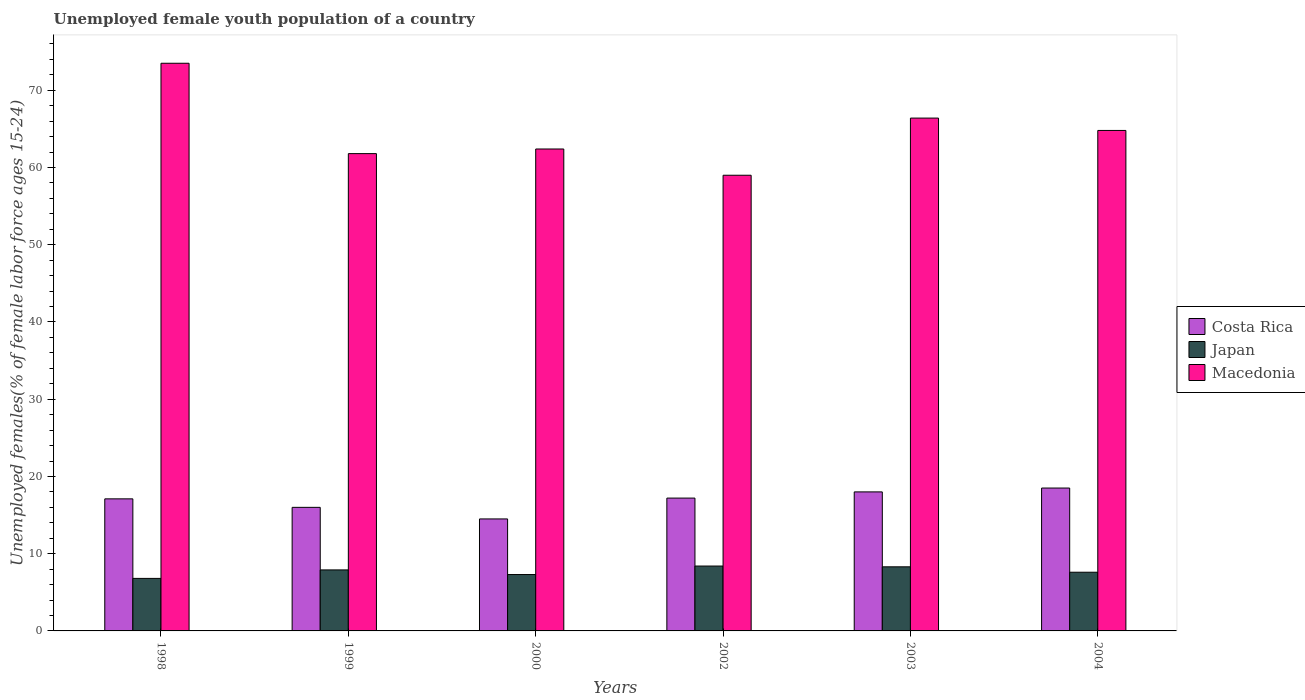Are the number of bars on each tick of the X-axis equal?
Keep it short and to the point. Yes. How many bars are there on the 5th tick from the left?
Provide a short and direct response. 3. What is the percentage of unemployed female youth population in Macedonia in 1998?
Your response must be concise. 73.5. Across all years, what is the maximum percentage of unemployed female youth population in Japan?
Offer a terse response. 8.4. Across all years, what is the minimum percentage of unemployed female youth population in Costa Rica?
Your response must be concise. 14.5. In which year was the percentage of unemployed female youth population in Macedonia maximum?
Your answer should be very brief. 1998. What is the total percentage of unemployed female youth population in Costa Rica in the graph?
Ensure brevity in your answer.  101.3. What is the difference between the percentage of unemployed female youth population in Macedonia in 1998 and that in 1999?
Offer a terse response. 11.7. What is the difference between the percentage of unemployed female youth population in Japan in 1998 and the percentage of unemployed female youth population in Costa Rica in 2002?
Your answer should be very brief. -10.4. What is the average percentage of unemployed female youth population in Japan per year?
Your answer should be very brief. 7.72. In the year 2003, what is the difference between the percentage of unemployed female youth population in Macedonia and percentage of unemployed female youth population in Japan?
Your answer should be very brief. 58.1. What is the ratio of the percentage of unemployed female youth population in Japan in 1999 to that in 2002?
Offer a very short reply. 0.94. Is the percentage of unemployed female youth population in Macedonia in 1998 less than that in 2000?
Keep it short and to the point. No. What is the difference between the highest and the second highest percentage of unemployed female youth population in Costa Rica?
Offer a terse response. 0.5. What does the 3rd bar from the left in 2003 represents?
Ensure brevity in your answer.  Macedonia. What does the 3rd bar from the right in 2000 represents?
Your answer should be very brief. Costa Rica. How many bars are there?
Give a very brief answer. 18. Are the values on the major ticks of Y-axis written in scientific E-notation?
Provide a short and direct response. No. Does the graph contain grids?
Your answer should be compact. No. How many legend labels are there?
Provide a short and direct response. 3. How are the legend labels stacked?
Your answer should be compact. Vertical. What is the title of the graph?
Your answer should be compact. Unemployed female youth population of a country. Does "Malta" appear as one of the legend labels in the graph?
Ensure brevity in your answer.  No. What is the label or title of the Y-axis?
Ensure brevity in your answer.  Unemployed females(% of female labor force ages 15-24). What is the Unemployed females(% of female labor force ages 15-24) of Costa Rica in 1998?
Your response must be concise. 17.1. What is the Unemployed females(% of female labor force ages 15-24) of Japan in 1998?
Your response must be concise. 6.8. What is the Unemployed females(% of female labor force ages 15-24) of Macedonia in 1998?
Offer a very short reply. 73.5. What is the Unemployed females(% of female labor force ages 15-24) in Japan in 1999?
Your answer should be very brief. 7.9. What is the Unemployed females(% of female labor force ages 15-24) of Macedonia in 1999?
Keep it short and to the point. 61.8. What is the Unemployed females(% of female labor force ages 15-24) in Japan in 2000?
Give a very brief answer. 7.3. What is the Unemployed females(% of female labor force ages 15-24) of Macedonia in 2000?
Offer a terse response. 62.4. What is the Unemployed females(% of female labor force ages 15-24) of Costa Rica in 2002?
Ensure brevity in your answer.  17.2. What is the Unemployed females(% of female labor force ages 15-24) in Japan in 2002?
Offer a very short reply. 8.4. What is the Unemployed females(% of female labor force ages 15-24) of Japan in 2003?
Your answer should be very brief. 8.3. What is the Unemployed females(% of female labor force ages 15-24) of Macedonia in 2003?
Provide a short and direct response. 66.4. What is the Unemployed females(% of female labor force ages 15-24) of Japan in 2004?
Ensure brevity in your answer.  7.6. What is the Unemployed females(% of female labor force ages 15-24) in Macedonia in 2004?
Provide a succinct answer. 64.8. Across all years, what is the maximum Unemployed females(% of female labor force ages 15-24) in Japan?
Your response must be concise. 8.4. Across all years, what is the maximum Unemployed females(% of female labor force ages 15-24) of Macedonia?
Offer a very short reply. 73.5. Across all years, what is the minimum Unemployed females(% of female labor force ages 15-24) of Costa Rica?
Offer a terse response. 14.5. Across all years, what is the minimum Unemployed females(% of female labor force ages 15-24) of Japan?
Your response must be concise. 6.8. Across all years, what is the minimum Unemployed females(% of female labor force ages 15-24) in Macedonia?
Your answer should be compact. 59. What is the total Unemployed females(% of female labor force ages 15-24) in Costa Rica in the graph?
Ensure brevity in your answer.  101.3. What is the total Unemployed females(% of female labor force ages 15-24) in Japan in the graph?
Your answer should be compact. 46.3. What is the total Unemployed females(% of female labor force ages 15-24) in Macedonia in the graph?
Your answer should be compact. 387.9. What is the difference between the Unemployed females(% of female labor force ages 15-24) in Japan in 1998 and that in 1999?
Give a very brief answer. -1.1. What is the difference between the Unemployed females(% of female labor force ages 15-24) of Costa Rica in 1998 and that in 2000?
Your answer should be compact. 2.6. What is the difference between the Unemployed females(% of female labor force ages 15-24) in Japan in 1998 and that in 2002?
Your answer should be compact. -1.6. What is the difference between the Unemployed females(% of female labor force ages 15-24) in Macedonia in 1998 and that in 2002?
Offer a terse response. 14.5. What is the difference between the Unemployed females(% of female labor force ages 15-24) of Japan in 1998 and that in 2003?
Your answer should be very brief. -1.5. What is the difference between the Unemployed females(% of female labor force ages 15-24) in Macedonia in 1998 and that in 2003?
Provide a short and direct response. 7.1. What is the difference between the Unemployed females(% of female labor force ages 15-24) of Costa Rica in 1998 and that in 2004?
Offer a terse response. -1.4. What is the difference between the Unemployed females(% of female labor force ages 15-24) of Costa Rica in 1999 and that in 2000?
Give a very brief answer. 1.5. What is the difference between the Unemployed females(% of female labor force ages 15-24) in Japan in 1999 and that in 2002?
Your answer should be very brief. -0.5. What is the difference between the Unemployed females(% of female labor force ages 15-24) of Macedonia in 1999 and that in 2002?
Give a very brief answer. 2.8. What is the difference between the Unemployed females(% of female labor force ages 15-24) of Costa Rica in 1999 and that in 2003?
Offer a very short reply. -2. What is the difference between the Unemployed females(% of female labor force ages 15-24) in Macedonia in 1999 and that in 2003?
Your answer should be very brief. -4.6. What is the difference between the Unemployed females(% of female labor force ages 15-24) in Japan in 2000 and that in 2002?
Keep it short and to the point. -1.1. What is the difference between the Unemployed females(% of female labor force ages 15-24) in Macedonia in 2000 and that in 2002?
Ensure brevity in your answer.  3.4. What is the difference between the Unemployed females(% of female labor force ages 15-24) of Costa Rica in 2000 and that in 2003?
Offer a very short reply. -3.5. What is the difference between the Unemployed females(% of female labor force ages 15-24) of Japan in 2000 and that in 2004?
Give a very brief answer. -0.3. What is the difference between the Unemployed females(% of female labor force ages 15-24) in Costa Rica in 2002 and that in 2003?
Provide a succinct answer. -0.8. What is the difference between the Unemployed females(% of female labor force ages 15-24) in Macedonia in 2002 and that in 2003?
Offer a terse response. -7.4. What is the difference between the Unemployed females(% of female labor force ages 15-24) in Japan in 2002 and that in 2004?
Give a very brief answer. 0.8. What is the difference between the Unemployed females(% of female labor force ages 15-24) in Macedonia in 2002 and that in 2004?
Offer a very short reply. -5.8. What is the difference between the Unemployed females(% of female labor force ages 15-24) in Costa Rica in 2003 and that in 2004?
Keep it short and to the point. -0.5. What is the difference between the Unemployed females(% of female labor force ages 15-24) of Japan in 2003 and that in 2004?
Your answer should be very brief. 0.7. What is the difference between the Unemployed females(% of female labor force ages 15-24) in Macedonia in 2003 and that in 2004?
Give a very brief answer. 1.6. What is the difference between the Unemployed females(% of female labor force ages 15-24) of Costa Rica in 1998 and the Unemployed females(% of female labor force ages 15-24) of Macedonia in 1999?
Offer a very short reply. -44.7. What is the difference between the Unemployed females(% of female labor force ages 15-24) in Japan in 1998 and the Unemployed females(% of female labor force ages 15-24) in Macedonia in 1999?
Your response must be concise. -55. What is the difference between the Unemployed females(% of female labor force ages 15-24) of Costa Rica in 1998 and the Unemployed females(% of female labor force ages 15-24) of Japan in 2000?
Ensure brevity in your answer.  9.8. What is the difference between the Unemployed females(% of female labor force ages 15-24) of Costa Rica in 1998 and the Unemployed females(% of female labor force ages 15-24) of Macedonia in 2000?
Make the answer very short. -45.3. What is the difference between the Unemployed females(% of female labor force ages 15-24) in Japan in 1998 and the Unemployed females(% of female labor force ages 15-24) in Macedonia in 2000?
Ensure brevity in your answer.  -55.6. What is the difference between the Unemployed females(% of female labor force ages 15-24) of Costa Rica in 1998 and the Unemployed females(% of female labor force ages 15-24) of Macedonia in 2002?
Provide a succinct answer. -41.9. What is the difference between the Unemployed females(% of female labor force ages 15-24) in Japan in 1998 and the Unemployed females(% of female labor force ages 15-24) in Macedonia in 2002?
Make the answer very short. -52.2. What is the difference between the Unemployed females(% of female labor force ages 15-24) in Costa Rica in 1998 and the Unemployed females(% of female labor force ages 15-24) in Japan in 2003?
Your answer should be compact. 8.8. What is the difference between the Unemployed females(% of female labor force ages 15-24) of Costa Rica in 1998 and the Unemployed females(% of female labor force ages 15-24) of Macedonia in 2003?
Your answer should be very brief. -49.3. What is the difference between the Unemployed females(% of female labor force ages 15-24) of Japan in 1998 and the Unemployed females(% of female labor force ages 15-24) of Macedonia in 2003?
Your answer should be compact. -59.6. What is the difference between the Unemployed females(% of female labor force ages 15-24) of Costa Rica in 1998 and the Unemployed females(% of female labor force ages 15-24) of Japan in 2004?
Make the answer very short. 9.5. What is the difference between the Unemployed females(% of female labor force ages 15-24) in Costa Rica in 1998 and the Unemployed females(% of female labor force ages 15-24) in Macedonia in 2004?
Provide a short and direct response. -47.7. What is the difference between the Unemployed females(% of female labor force ages 15-24) of Japan in 1998 and the Unemployed females(% of female labor force ages 15-24) of Macedonia in 2004?
Make the answer very short. -58. What is the difference between the Unemployed females(% of female labor force ages 15-24) of Costa Rica in 1999 and the Unemployed females(% of female labor force ages 15-24) of Japan in 2000?
Ensure brevity in your answer.  8.7. What is the difference between the Unemployed females(% of female labor force ages 15-24) in Costa Rica in 1999 and the Unemployed females(% of female labor force ages 15-24) in Macedonia in 2000?
Keep it short and to the point. -46.4. What is the difference between the Unemployed females(% of female labor force ages 15-24) of Japan in 1999 and the Unemployed females(% of female labor force ages 15-24) of Macedonia in 2000?
Offer a terse response. -54.5. What is the difference between the Unemployed females(% of female labor force ages 15-24) of Costa Rica in 1999 and the Unemployed females(% of female labor force ages 15-24) of Macedonia in 2002?
Your answer should be compact. -43. What is the difference between the Unemployed females(% of female labor force ages 15-24) in Japan in 1999 and the Unemployed females(% of female labor force ages 15-24) in Macedonia in 2002?
Give a very brief answer. -51.1. What is the difference between the Unemployed females(% of female labor force ages 15-24) of Costa Rica in 1999 and the Unemployed females(% of female labor force ages 15-24) of Macedonia in 2003?
Make the answer very short. -50.4. What is the difference between the Unemployed females(% of female labor force ages 15-24) of Japan in 1999 and the Unemployed females(% of female labor force ages 15-24) of Macedonia in 2003?
Your response must be concise. -58.5. What is the difference between the Unemployed females(% of female labor force ages 15-24) of Costa Rica in 1999 and the Unemployed females(% of female labor force ages 15-24) of Japan in 2004?
Keep it short and to the point. 8.4. What is the difference between the Unemployed females(% of female labor force ages 15-24) of Costa Rica in 1999 and the Unemployed females(% of female labor force ages 15-24) of Macedonia in 2004?
Provide a succinct answer. -48.8. What is the difference between the Unemployed females(% of female labor force ages 15-24) of Japan in 1999 and the Unemployed females(% of female labor force ages 15-24) of Macedonia in 2004?
Offer a very short reply. -56.9. What is the difference between the Unemployed females(% of female labor force ages 15-24) of Costa Rica in 2000 and the Unemployed females(% of female labor force ages 15-24) of Macedonia in 2002?
Provide a short and direct response. -44.5. What is the difference between the Unemployed females(% of female labor force ages 15-24) of Japan in 2000 and the Unemployed females(% of female labor force ages 15-24) of Macedonia in 2002?
Offer a terse response. -51.7. What is the difference between the Unemployed females(% of female labor force ages 15-24) of Costa Rica in 2000 and the Unemployed females(% of female labor force ages 15-24) of Macedonia in 2003?
Offer a terse response. -51.9. What is the difference between the Unemployed females(% of female labor force ages 15-24) of Japan in 2000 and the Unemployed females(% of female labor force ages 15-24) of Macedonia in 2003?
Make the answer very short. -59.1. What is the difference between the Unemployed females(% of female labor force ages 15-24) of Costa Rica in 2000 and the Unemployed females(% of female labor force ages 15-24) of Macedonia in 2004?
Keep it short and to the point. -50.3. What is the difference between the Unemployed females(% of female labor force ages 15-24) of Japan in 2000 and the Unemployed females(% of female labor force ages 15-24) of Macedonia in 2004?
Your answer should be very brief. -57.5. What is the difference between the Unemployed females(% of female labor force ages 15-24) in Costa Rica in 2002 and the Unemployed females(% of female labor force ages 15-24) in Macedonia in 2003?
Keep it short and to the point. -49.2. What is the difference between the Unemployed females(% of female labor force ages 15-24) in Japan in 2002 and the Unemployed females(% of female labor force ages 15-24) in Macedonia in 2003?
Keep it short and to the point. -58. What is the difference between the Unemployed females(% of female labor force ages 15-24) in Costa Rica in 2002 and the Unemployed females(% of female labor force ages 15-24) in Japan in 2004?
Ensure brevity in your answer.  9.6. What is the difference between the Unemployed females(% of female labor force ages 15-24) in Costa Rica in 2002 and the Unemployed females(% of female labor force ages 15-24) in Macedonia in 2004?
Provide a succinct answer. -47.6. What is the difference between the Unemployed females(% of female labor force ages 15-24) in Japan in 2002 and the Unemployed females(% of female labor force ages 15-24) in Macedonia in 2004?
Keep it short and to the point. -56.4. What is the difference between the Unemployed females(% of female labor force ages 15-24) of Costa Rica in 2003 and the Unemployed females(% of female labor force ages 15-24) of Japan in 2004?
Offer a very short reply. 10.4. What is the difference between the Unemployed females(% of female labor force ages 15-24) in Costa Rica in 2003 and the Unemployed females(% of female labor force ages 15-24) in Macedonia in 2004?
Ensure brevity in your answer.  -46.8. What is the difference between the Unemployed females(% of female labor force ages 15-24) in Japan in 2003 and the Unemployed females(% of female labor force ages 15-24) in Macedonia in 2004?
Give a very brief answer. -56.5. What is the average Unemployed females(% of female labor force ages 15-24) in Costa Rica per year?
Make the answer very short. 16.88. What is the average Unemployed females(% of female labor force ages 15-24) of Japan per year?
Your answer should be compact. 7.72. What is the average Unemployed females(% of female labor force ages 15-24) in Macedonia per year?
Give a very brief answer. 64.65. In the year 1998, what is the difference between the Unemployed females(% of female labor force ages 15-24) of Costa Rica and Unemployed females(% of female labor force ages 15-24) of Japan?
Your answer should be very brief. 10.3. In the year 1998, what is the difference between the Unemployed females(% of female labor force ages 15-24) in Costa Rica and Unemployed females(% of female labor force ages 15-24) in Macedonia?
Provide a succinct answer. -56.4. In the year 1998, what is the difference between the Unemployed females(% of female labor force ages 15-24) of Japan and Unemployed females(% of female labor force ages 15-24) of Macedonia?
Ensure brevity in your answer.  -66.7. In the year 1999, what is the difference between the Unemployed females(% of female labor force ages 15-24) in Costa Rica and Unemployed females(% of female labor force ages 15-24) in Macedonia?
Provide a short and direct response. -45.8. In the year 1999, what is the difference between the Unemployed females(% of female labor force ages 15-24) of Japan and Unemployed females(% of female labor force ages 15-24) of Macedonia?
Offer a very short reply. -53.9. In the year 2000, what is the difference between the Unemployed females(% of female labor force ages 15-24) of Costa Rica and Unemployed females(% of female labor force ages 15-24) of Japan?
Your response must be concise. 7.2. In the year 2000, what is the difference between the Unemployed females(% of female labor force ages 15-24) of Costa Rica and Unemployed females(% of female labor force ages 15-24) of Macedonia?
Offer a terse response. -47.9. In the year 2000, what is the difference between the Unemployed females(% of female labor force ages 15-24) in Japan and Unemployed females(% of female labor force ages 15-24) in Macedonia?
Make the answer very short. -55.1. In the year 2002, what is the difference between the Unemployed females(% of female labor force ages 15-24) of Costa Rica and Unemployed females(% of female labor force ages 15-24) of Macedonia?
Provide a short and direct response. -41.8. In the year 2002, what is the difference between the Unemployed females(% of female labor force ages 15-24) in Japan and Unemployed females(% of female labor force ages 15-24) in Macedonia?
Give a very brief answer. -50.6. In the year 2003, what is the difference between the Unemployed females(% of female labor force ages 15-24) of Costa Rica and Unemployed females(% of female labor force ages 15-24) of Japan?
Provide a short and direct response. 9.7. In the year 2003, what is the difference between the Unemployed females(% of female labor force ages 15-24) of Costa Rica and Unemployed females(% of female labor force ages 15-24) of Macedonia?
Offer a very short reply. -48.4. In the year 2003, what is the difference between the Unemployed females(% of female labor force ages 15-24) in Japan and Unemployed females(% of female labor force ages 15-24) in Macedonia?
Your answer should be compact. -58.1. In the year 2004, what is the difference between the Unemployed females(% of female labor force ages 15-24) in Costa Rica and Unemployed females(% of female labor force ages 15-24) in Japan?
Offer a terse response. 10.9. In the year 2004, what is the difference between the Unemployed females(% of female labor force ages 15-24) of Costa Rica and Unemployed females(% of female labor force ages 15-24) of Macedonia?
Offer a terse response. -46.3. In the year 2004, what is the difference between the Unemployed females(% of female labor force ages 15-24) in Japan and Unemployed females(% of female labor force ages 15-24) in Macedonia?
Offer a very short reply. -57.2. What is the ratio of the Unemployed females(% of female labor force ages 15-24) in Costa Rica in 1998 to that in 1999?
Ensure brevity in your answer.  1.07. What is the ratio of the Unemployed females(% of female labor force ages 15-24) in Japan in 1998 to that in 1999?
Your answer should be very brief. 0.86. What is the ratio of the Unemployed females(% of female labor force ages 15-24) in Macedonia in 1998 to that in 1999?
Provide a succinct answer. 1.19. What is the ratio of the Unemployed females(% of female labor force ages 15-24) in Costa Rica in 1998 to that in 2000?
Offer a very short reply. 1.18. What is the ratio of the Unemployed females(% of female labor force ages 15-24) of Japan in 1998 to that in 2000?
Provide a short and direct response. 0.93. What is the ratio of the Unemployed females(% of female labor force ages 15-24) in Macedonia in 1998 to that in 2000?
Give a very brief answer. 1.18. What is the ratio of the Unemployed females(% of female labor force ages 15-24) of Japan in 1998 to that in 2002?
Keep it short and to the point. 0.81. What is the ratio of the Unemployed females(% of female labor force ages 15-24) of Macedonia in 1998 to that in 2002?
Offer a very short reply. 1.25. What is the ratio of the Unemployed females(% of female labor force ages 15-24) of Costa Rica in 1998 to that in 2003?
Provide a short and direct response. 0.95. What is the ratio of the Unemployed females(% of female labor force ages 15-24) in Japan in 1998 to that in 2003?
Offer a very short reply. 0.82. What is the ratio of the Unemployed females(% of female labor force ages 15-24) of Macedonia in 1998 to that in 2003?
Keep it short and to the point. 1.11. What is the ratio of the Unemployed females(% of female labor force ages 15-24) in Costa Rica in 1998 to that in 2004?
Ensure brevity in your answer.  0.92. What is the ratio of the Unemployed females(% of female labor force ages 15-24) in Japan in 1998 to that in 2004?
Your answer should be compact. 0.89. What is the ratio of the Unemployed females(% of female labor force ages 15-24) in Macedonia in 1998 to that in 2004?
Make the answer very short. 1.13. What is the ratio of the Unemployed females(% of female labor force ages 15-24) of Costa Rica in 1999 to that in 2000?
Offer a terse response. 1.1. What is the ratio of the Unemployed females(% of female labor force ages 15-24) of Japan in 1999 to that in 2000?
Provide a short and direct response. 1.08. What is the ratio of the Unemployed females(% of female labor force ages 15-24) of Macedonia in 1999 to that in 2000?
Offer a terse response. 0.99. What is the ratio of the Unemployed females(% of female labor force ages 15-24) of Costa Rica in 1999 to that in 2002?
Provide a succinct answer. 0.93. What is the ratio of the Unemployed females(% of female labor force ages 15-24) of Japan in 1999 to that in 2002?
Offer a very short reply. 0.94. What is the ratio of the Unemployed females(% of female labor force ages 15-24) of Macedonia in 1999 to that in 2002?
Offer a terse response. 1.05. What is the ratio of the Unemployed females(% of female labor force ages 15-24) of Japan in 1999 to that in 2003?
Offer a very short reply. 0.95. What is the ratio of the Unemployed females(% of female labor force ages 15-24) of Macedonia in 1999 to that in 2003?
Give a very brief answer. 0.93. What is the ratio of the Unemployed females(% of female labor force ages 15-24) of Costa Rica in 1999 to that in 2004?
Your response must be concise. 0.86. What is the ratio of the Unemployed females(% of female labor force ages 15-24) of Japan in 1999 to that in 2004?
Offer a terse response. 1.04. What is the ratio of the Unemployed females(% of female labor force ages 15-24) of Macedonia in 1999 to that in 2004?
Your answer should be very brief. 0.95. What is the ratio of the Unemployed females(% of female labor force ages 15-24) of Costa Rica in 2000 to that in 2002?
Offer a very short reply. 0.84. What is the ratio of the Unemployed females(% of female labor force ages 15-24) in Japan in 2000 to that in 2002?
Make the answer very short. 0.87. What is the ratio of the Unemployed females(% of female labor force ages 15-24) of Macedonia in 2000 to that in 2002?
Keep it short and to the point. 1.06. What is the ratio of the Unemployed females(% of female labor force ages 15-24) of Costa Rica in 2000 to that in 2003?
Keep it short and to the point. 0.81. What is the ratio of the Unemployed females(% of female labor force ages 15-24) in Japan in 2000 to that in 2003?
Give a very brief answer. 0.88. What is the ratio of the Unemployed females(% of female labor force ages 15-24) in Macedonia in 2000 to that in 2003?
Keep it short and to the point. 0.94. What is the ratio of the Unemployed females(% of female labor force ages 15-24) of Costa Rica in 2000 to that in 2004?
Keep it short and to the point. 0.78. What is the ratio of the Unemployed females(% of female labor force ages 15-24) in Japan in 2000 to that in 2004?
Make the answer very short. 0.96. What is the ratio of the Unemployed females(% of female labor force ages 15-24) of Costa Rica in 2002 to that in 2003?
Ensure brevity in your answer.  0.96. What is the ratio of the Unemployed females(% of female labor force ages 15-24) in Macedonia in 2002 to that in 2003?
Make the answer very short. 0.89. What is the ratio of the Unemployed females(% of female labor force ages 15-24) in Costa Rica in 2002 to that in 2004?
Provide a short and direct response. 0.93. What is the ratio of the Unemployed females(% of female labor force ages 15-24) in Japan in 2002 to that in 2004?
Offer a very short reply. 1.11. What is the ratio of the Unemployed females(% of female labor force ages 15-24) of Macedonia in 2002 to that in 2004?
Make the answer very short. 0.91. What is the ratio of the Unemployed females(% of female labor force ages 15-24) of Costa Rica in 2003 to that in 2004?
Your answer should be very brief. 0.97. What is the ratio of the Unemployed females(% of female labor force ages 15-24) of Japan in 2003 to that in 2004?
Keep it short and to the point. 1.09. What is the ratio of the Unemployed females(% of female labor force ages 15-24) in Macedonia in 2003 to that in 2004?
Provide a short and direct response. 1.02. What is the difference between the highest and the second highest Unemployed females(% of female labor force ages 15-24) of Costa Rica?
Provide a short and direct response. 0.5. What is the difference between the highest and the second highest Unemployed females(% of female labor force ages 15-24) of Macedonia?
Your answer should be compact. 7.1. What is the difference between the highest and the lowest Unemployed females(% of female labor force ages 15-24) of Costa Rica?
Ensure brevity in your answer.  4. 